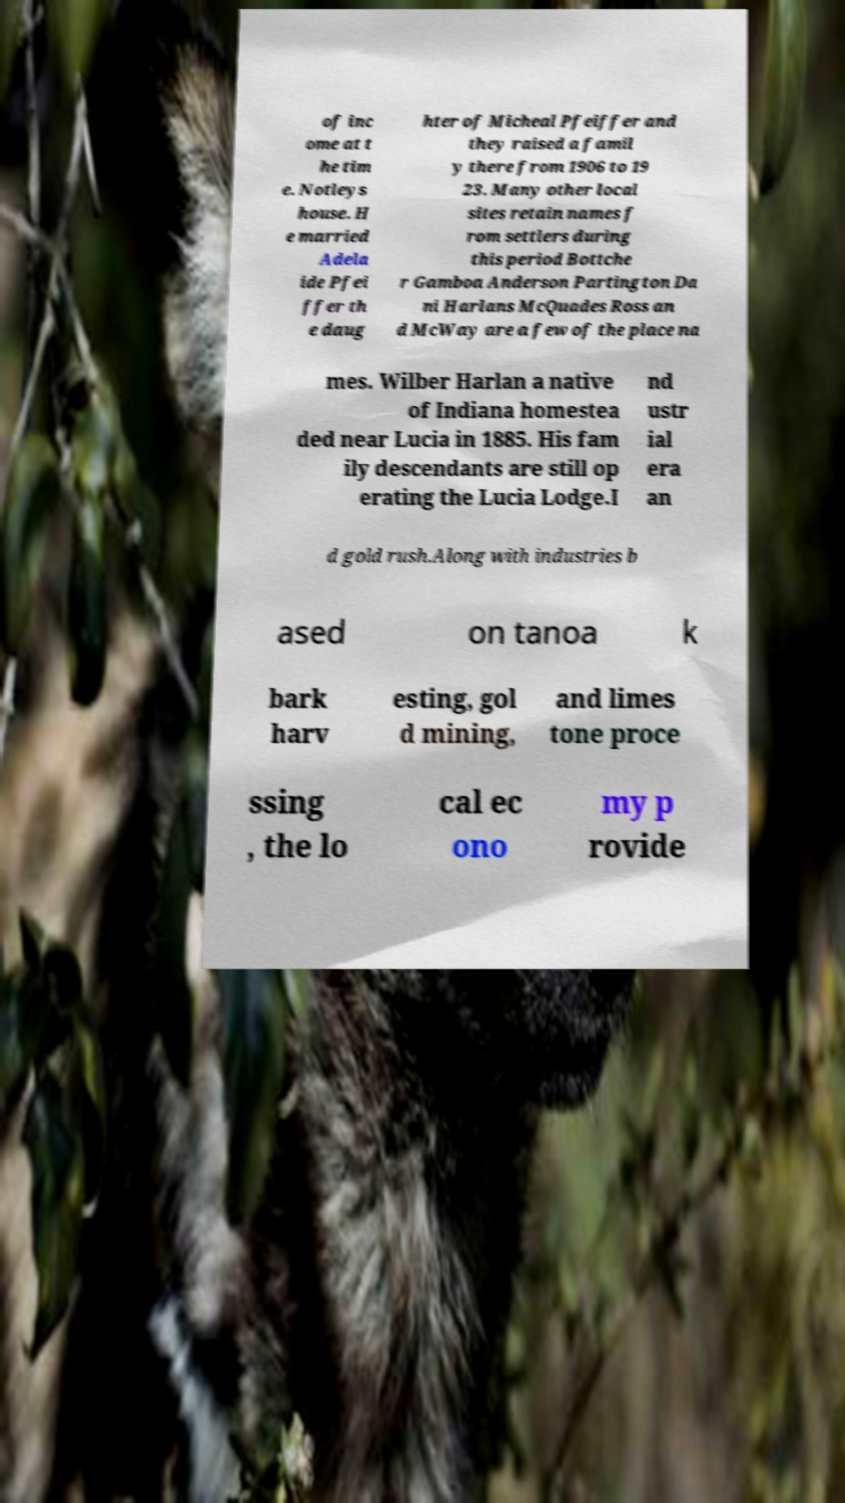Please identify and transcribe the text found in this image. of inc ome at t he tim e. Notleys house. H e married Adela ide Pfei ffer th e daug hter of Micheal Pfeiffer and they raised a famil y there from 1906 to 19 23. Many other local sites retain names f rom settlers during this period Bottche r Gamboa Anderson Partington Da ni Harlans McQuades Ross an d McWay are a few of the place na mes. Wilber Harlan a native of Indiana homestea ded near Lucia in 1885. His fam ily descendants are still op erating the Lucia Lodge.I nd ustr ial era an d gold rush.Along with industries b ased on tanoa k bark harv esting, gol d mining, and limes tone proce ssing , the lo cal ec ono my p rovide 